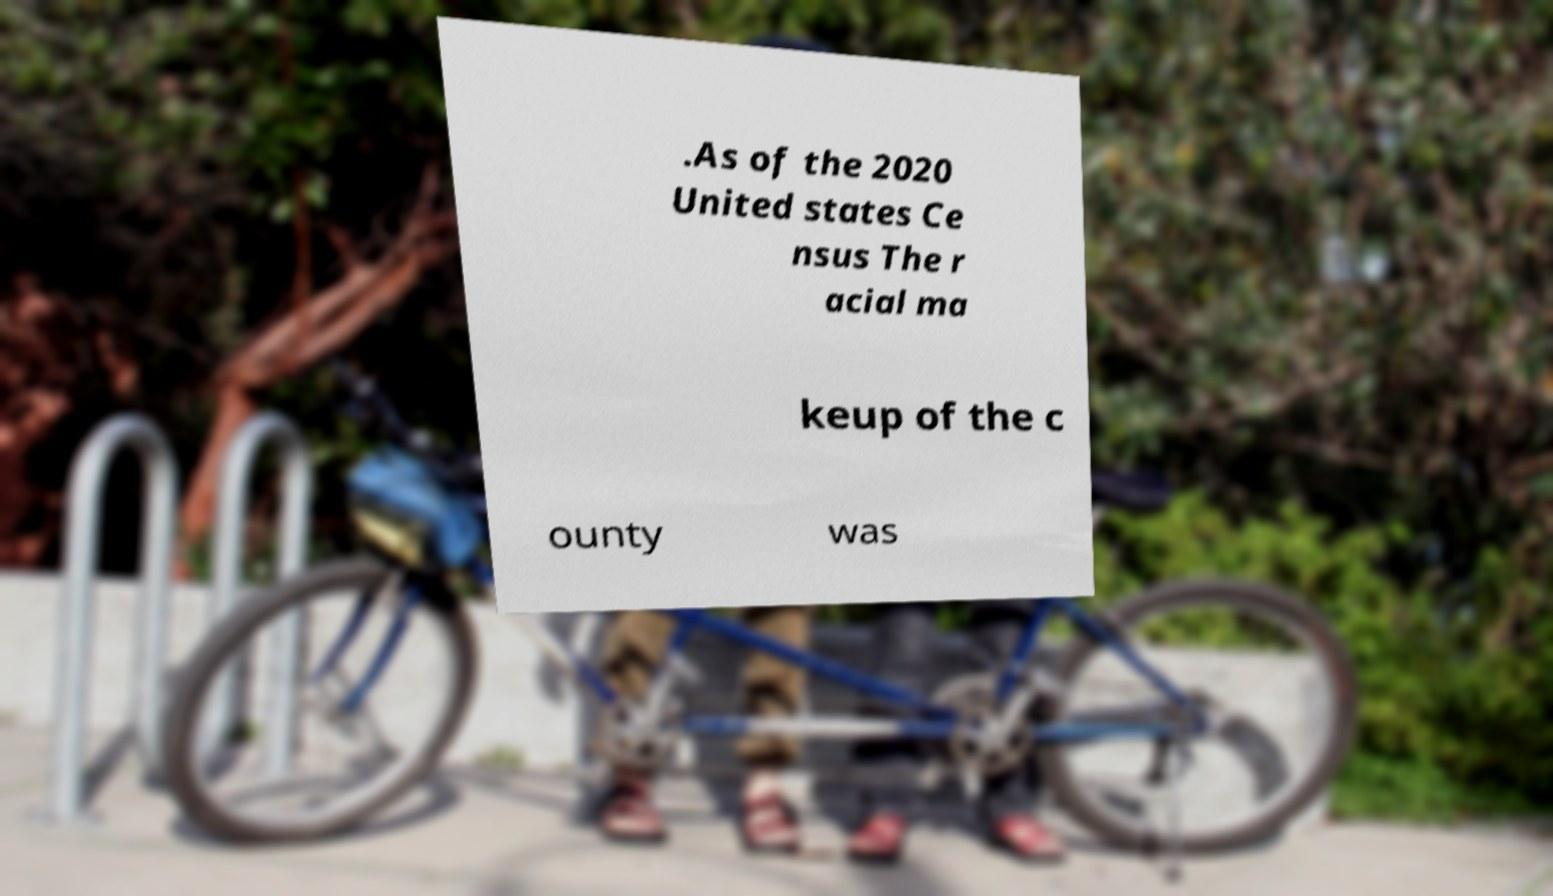Please read and relay the text visible in this image. What does it say? .As of the 2020 United states Ce nsus The r acial ma keup of the c ounty was 